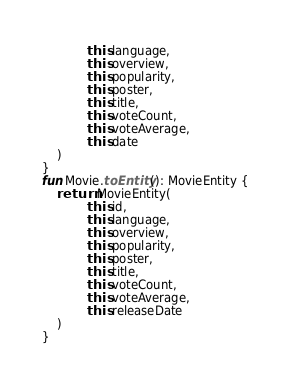<code> <loc_0><loc_0><loc_500><loc_500><_Kotlin_>            this.language,
            this.overview,
            this.popularity,
            this.poster,
            this.title,
            this.voteCount,
            this.voteAverage,
            this.date
    )
}
fun Movie.toEntity(): MovieEntity {
    return MovieEntity(
            this.id,
            this.language,
            this.overview,
            this.popularity,
            this.poster,
            this.title,
            this.voteCount,
            this.voteAverage,
            this.releaseDate
    )
}</code> 